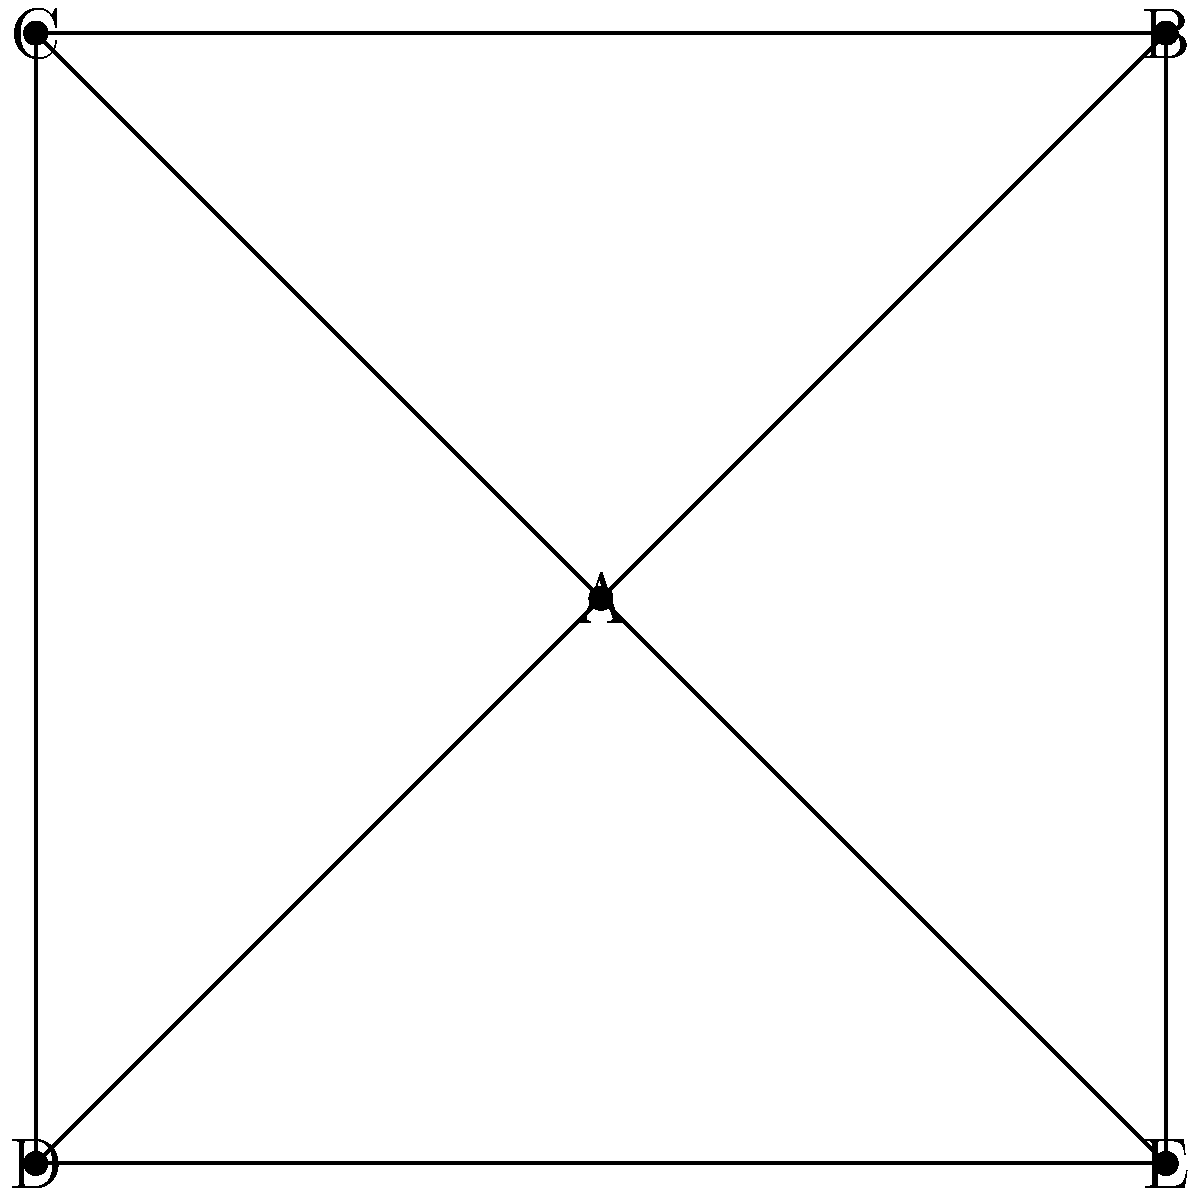In the given social network diagram, which individual has the highest degree centrality, and what does this suggest about their role in the community? To answer this question, we need to follow these steps:

1. Understand degree centrality:
   Degree centrality is the number of direct connections an individual has in a network.

2. Count connections for each node:
   A: 4 connections (to B, C, D, and E)
   B: 3 connections (to A, C, and E)
   C: 3 connections (to A, B, and D)
   D: 3 connections (to A, C, and E)
   E: 3 connections (to A, B, and D)

3. Identify the highest degree centrality:
   A has the highest degree centrality with 4 connections.

4. Interpret the meaning:
   The individual with the highest degree centrality (A) is likely to be:
   - A central figure in the community
   - Have more influence or access to information
   - Act as a bridge between different parts of the network

5. Sociological implications:
   This central position could indicate that A is a leader, facilitator, or key information broker in the community. However, it's important to note that other network measures and contextual factors should be considered for a comprehensive analysis.
Answer: A has the highest degree centrality (4 connections), suggesting they are a central, influential figure in the community. 